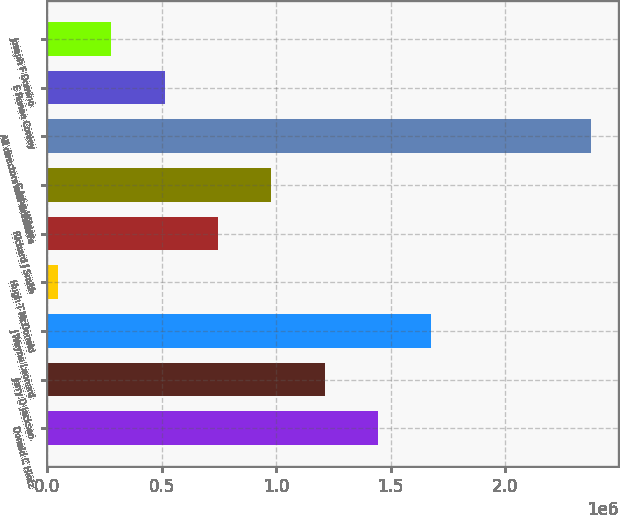Convert chart. <chart><loc_0><loc_0><loc_500><loc_500><bar_chart><fcel>Donald C Hintz<fcel>Jerry D Jackson<fcel>J Wayne Leonard<fcel>Hugh T McDonald<fcel>Richard J Smith<fcel>C John Wilder<fcel>All directors and executive<fcel>E Renae Conley<fcel>Joseph F Domino<nl><fcel>1.4451e+06<fcel>1.2123e+06<fcel>1.6779e+06<fcel>48300<fcel>746702<fcel>979502<fcel>2.37631e+06<fcel>513901<fcel>281101<nl></chart> 